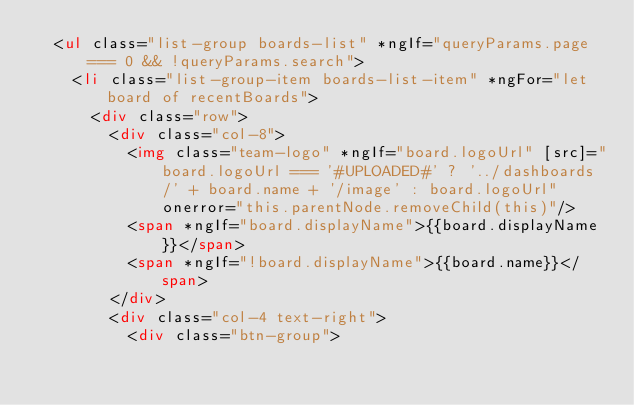<code> <loc_0><loc_0><loc_500><loc_500><_HTML_>  <ul class="list-group boards-list" *ngIf="queryParams.page === 0 && !queryParams.search">
    <li class="list-group-item boards-list-item" *ngFor="let board of recentBoards">
      <div class="row">
        <div class="col-8">
          <img class="team-logo" *ngIf="board.logoUrl" [src]="board.logoUrl === '#UPLOADED#' ? '../dashboards/' + board.name + '/image' : board.logoUrl"  onerror="this.parentNode.removeChild(this)"/>
          <span *ngIf="board.displayName">{{board.displayName}}</span>
          <span *ngIf="!board.displayName">{{board.name}}</span>
        </div>
        <div class="col-4 text-right">
          <div class="btn-group"></code> 